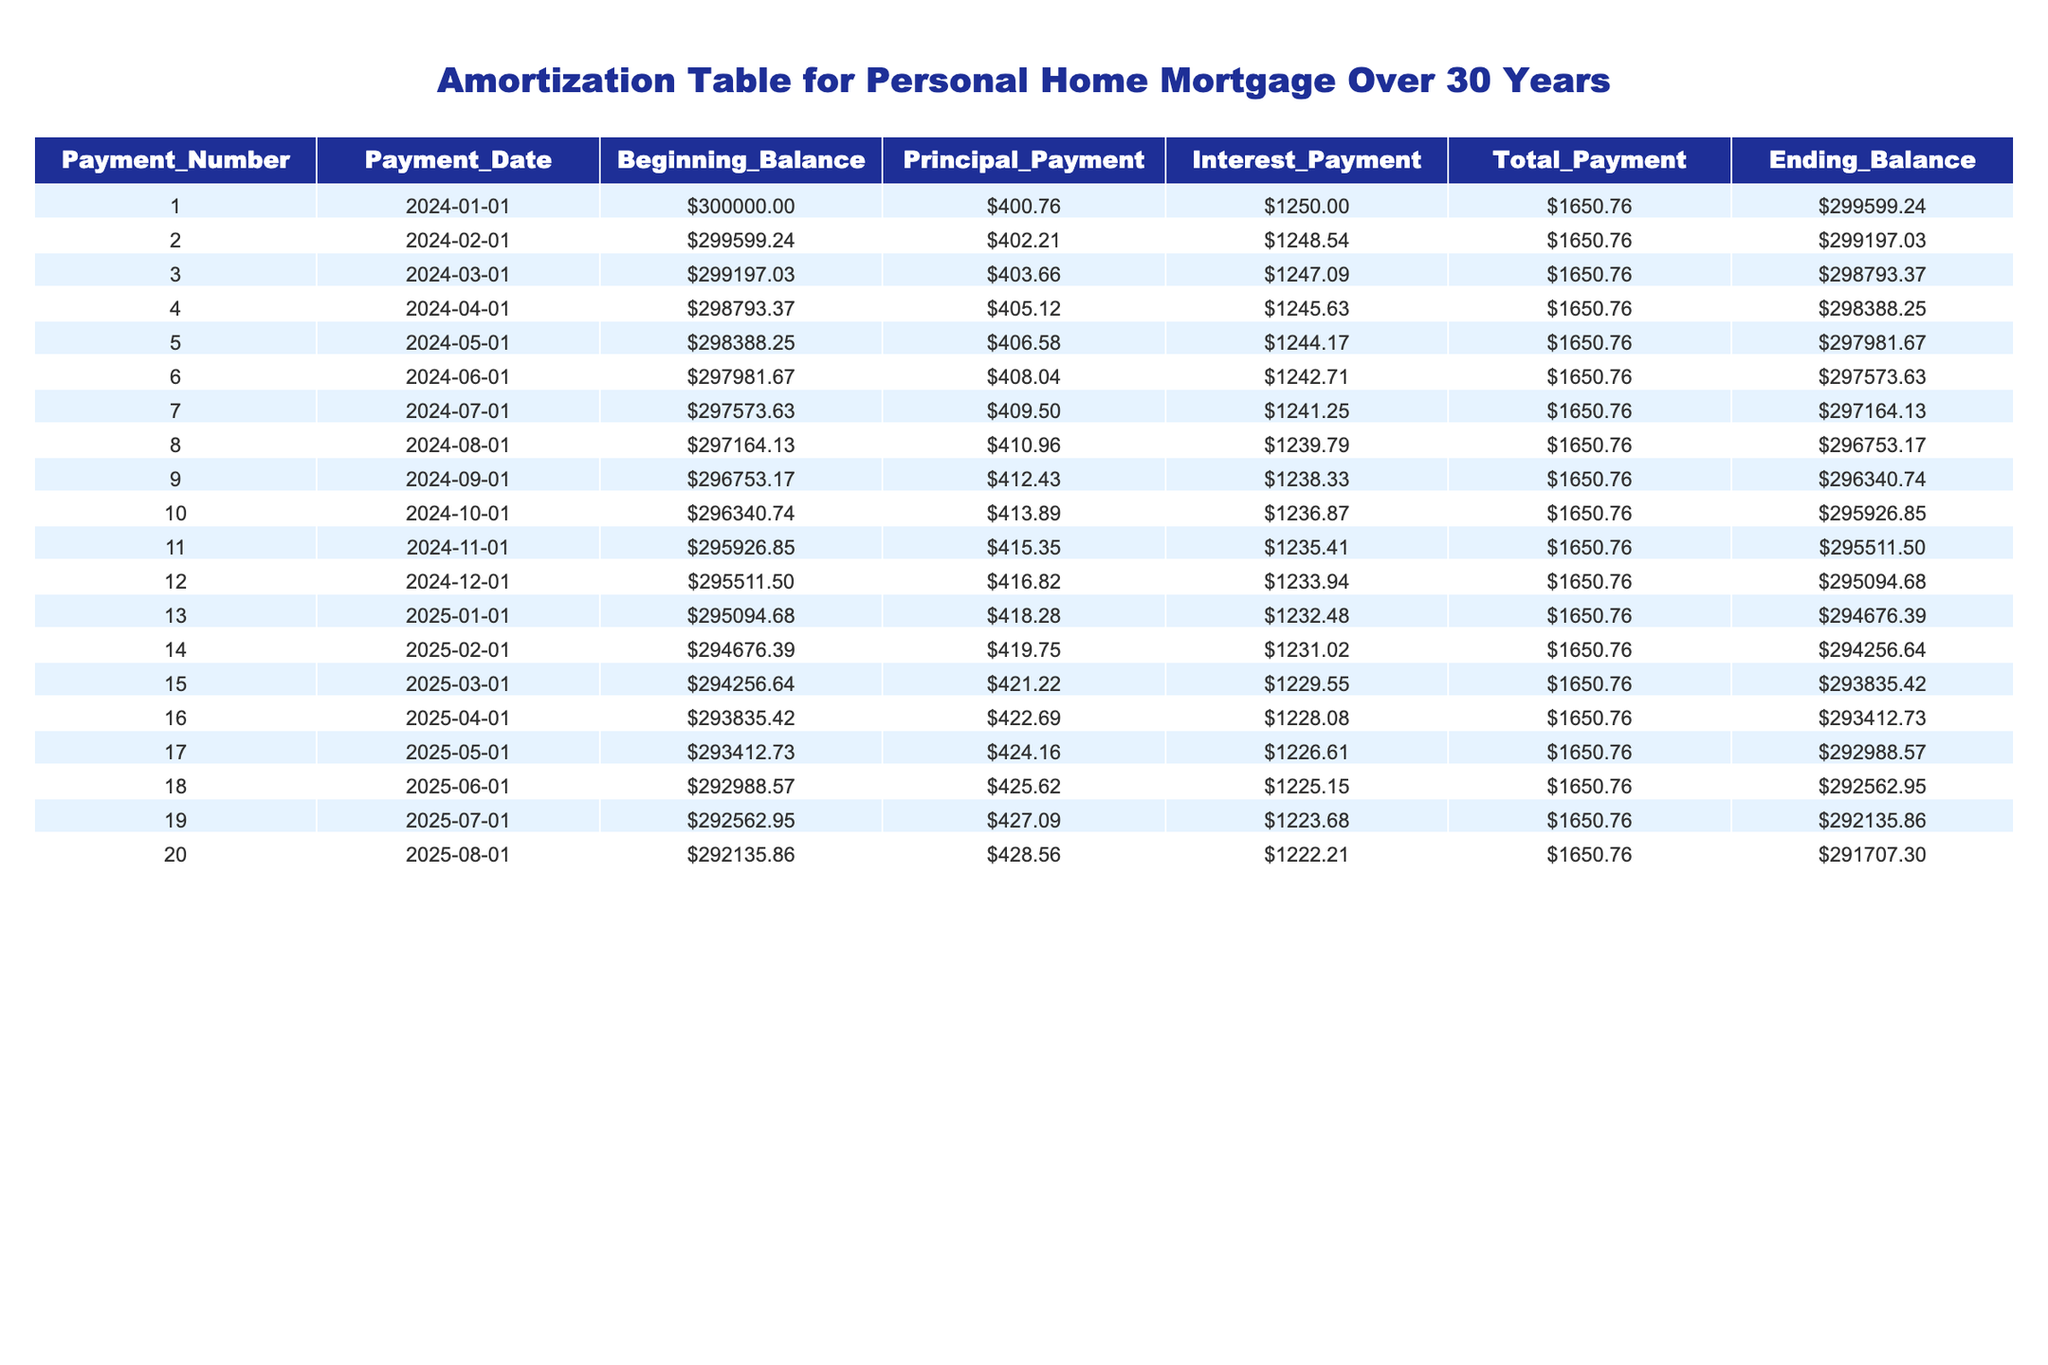What is the total payment for the first month? In the table, the total payment for the first month (Payment Number 1) can be found in the "Total_Payment" column. The value for Payment Number 1 is 1650.76.
Answer: 1650.76 What is the principal payment made in the sixth month? Referring to Payment Number 6 in the table, the principal payment is listed in the "Principal_Payment" column. For the sixth month, this value is 408.04.
Answer: 408.04 Is the interest payment for month 10 greater than the interest payment for month 5? To answer this, we look at the "Interest_Payment" column for both months. For month 10, the interest payment is 1236.87, and for month 5, it is 1244.17. Since 1236.87 is less than 1244.17, the answer is no.
Answer: No What is the average principal payment over the first three months? The principal payments for the first three months are 400.76, 402.21, and 403.66. We sum these values: 400.76 + 402.21 + 403.66 = 1206.63. We then divide by 3, resulting in an average of 1206.63 / 3 = 402.21.
Answer: 402.21 What is the total remaining balance after the first 20 payments? We need to refer to the "Ending_Balance" of the 20th payment. After Payment Number 20, the remaining balance is 291707.30 as indicated in the table under "Ending_Balance".
Answer: 291707.30 Which payment number has the largest principal payment? To find this, we compare the principal payment values in the "Principal_Payment" column across all payments and identify the maximum value. The largest principal payment is 428.56, which is for Payment Number 20.
Answer: 20 How much total interest was paid in the first five months? To calculate total interest over the first five months, we will add the "Interest_Payment" values for Payments 1 to 5. The total is 1250.00 + 1248.54 + 1247.09 + 1245.63 + 1244.17 = 6235.43.
Answer: 6235.43 Was the principal payment ever less than 400 in the recorded data? Looking through the "Principal_Payment" values provided, the minimum principal payment recorded is higher than 400. The lowest value is 400.76 in the first month. Therefore, the answer is no.
Answer: No 